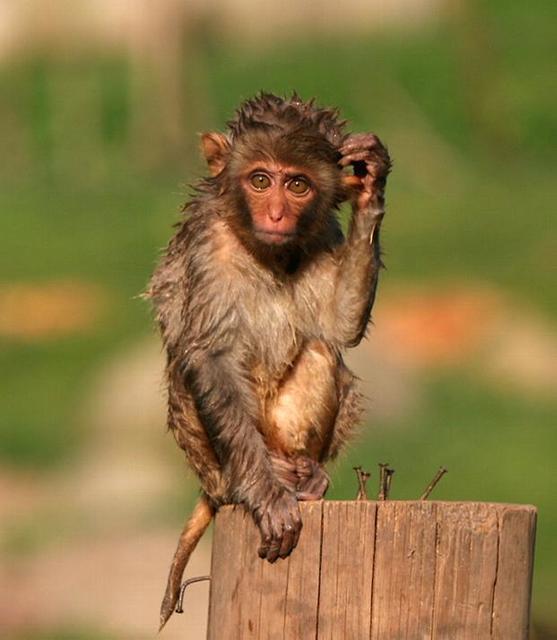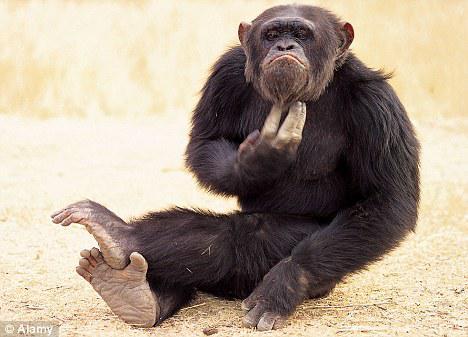The first image is the image on the left, the second image is the image on the right. Evaluate the accuracy of this statement regarding the images: "A small monkey with non-black fur scratches its head, in one image.". Is it true? Answer yes or no. Yes. The first image is the image on the left, the second image is the image on the right. For the images displayed, is the sentence "At least one primate is sticking their tongue out." factually correct? Answer yes or no. No. 